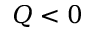<formula> <loc_0><loc_0><loc_500><loc_500>Q < 0</formula> 